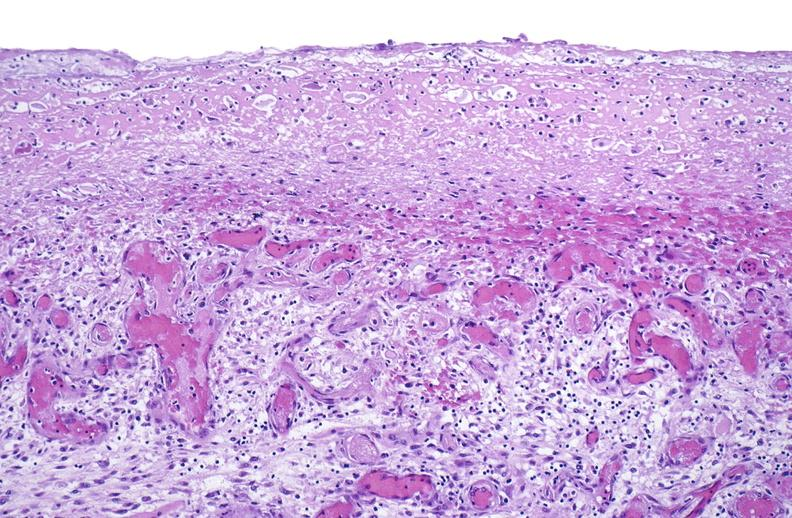s face present?
Answer the question using a single word or phrase. No 